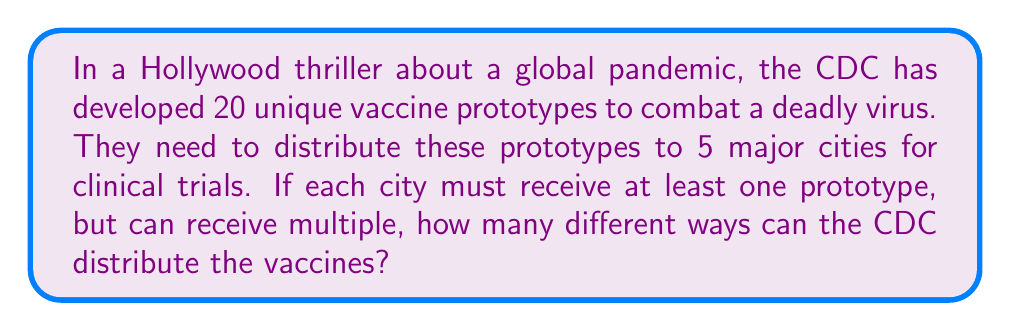Can you answer this question? Let's approach this step-by-step using the concept of distributing identical objects into distinct boxes:

1) This problem can be modeled as distributing 20 identical objects (vaccines) into 5 distinct boxes (cities), where no box can be empty.

2) In combinatorics, this is known as a "distribution of identical objects into distinct boxes with no empty boxes".

3) The formula for this scenario is:

   $$\binom{n-1}{k-1}$$

   Where $n$ is the number of objects plus the number of boxes, and $k$ is the number of boxes.

4) In our case:
   $n = 20 + 5 = 25$ (20 vaccines + 5 cities)
   $k = 5$ (5 cities)

5) Plugging these values into the formula:

   $$\binom{25-1}{5-1} = \binom{24}{4}$$

6) We can calculate this using the combination formula:

   $$\binom{24}{4} = \frac{24!}{4!(24-4)!} = \frac{24!}{4!20!}$$

7) Evaluating this:
   
   $$\frac{24 * 23 * 22 * 21}{4 * 3 * 2 * 1} = 10,626$$

Therefore, there are 10,626 different ways to distribute the vaccines.
Answer: 10,626 